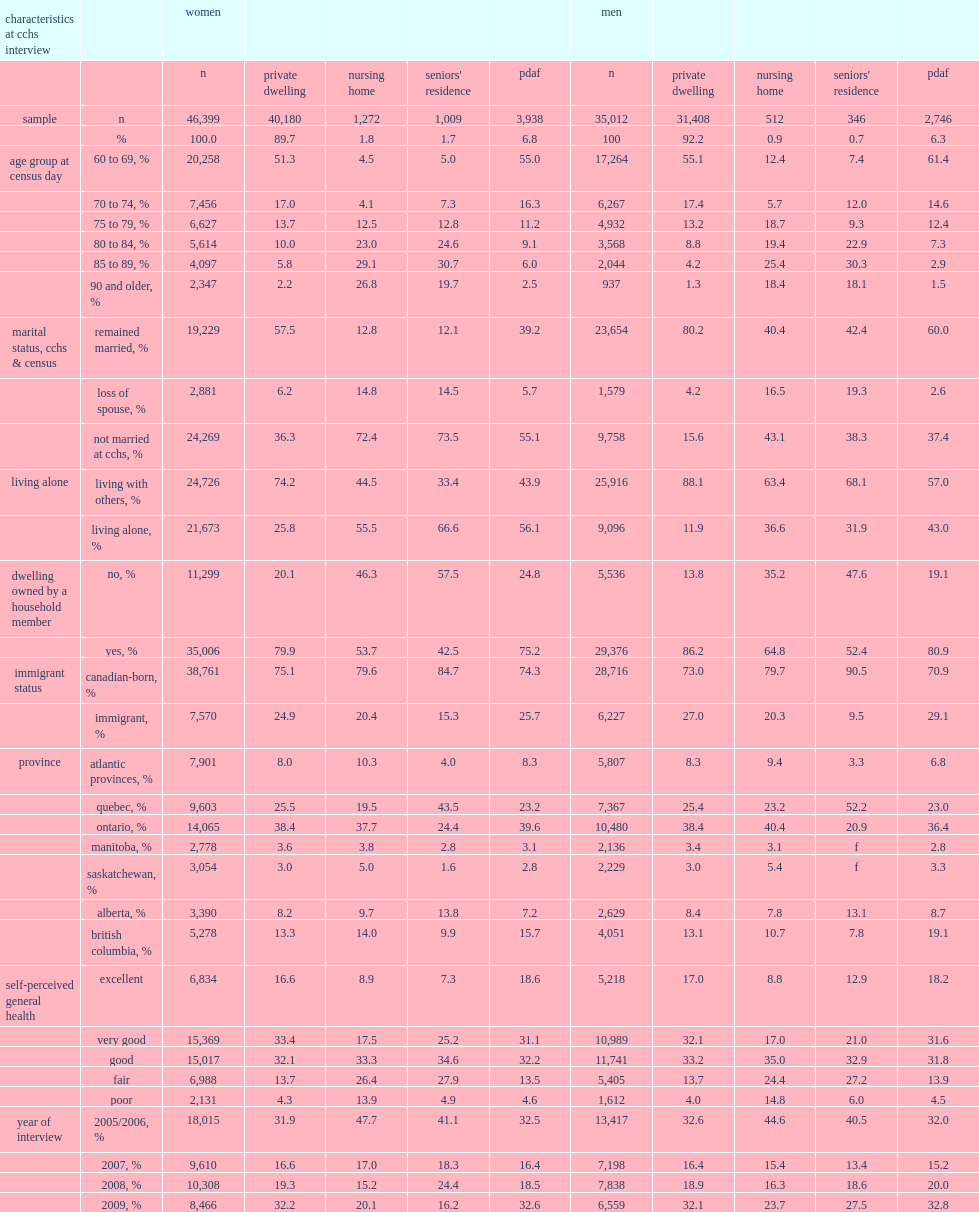Would you be able to parse every entry in this table? {'header': ['characteristics at cchs interview', '', 'women', '', '', '', '', 'men', '', '', '', ''], 'rows': [['', '', 'n', 'private dwelling', 'nursing home', "seniors' residence", 'pdaf', 'n', 'private dwelling', 'nursing home', "seniors' residence", 'pdaf'], ['sample', 'n', '46,399', '40,180', '1,272', '1,009', '3,938', '35,012', '31,408', '512', '346', '2,746'], ['', '%', '100.0', '89.7', '1.8', '1.7', '6.8', '100', '92.2', '0.9', '0.7', '6.3'], ['age group at census day', '60 to 69, %', '20,258', '51.3', '4.5', '5.0', '55.0', '17,264', '55.1', '12.4', '7.4', '61.4'], ['', '70 to 74, %', '7,456', '17.0', '4.1', '7.3', '16.3', '6,267', '17.4', '5.7', '12.0', '14.6'], ['', '75 to 79, %', '6,627', '13.7', '12.5', '12.8', '11.2', '4,932', '13.2', '18.7', '9.3', '12.4'], ['', '80 to 84, %', '5,614', '10.0', '23.0', '24.6', '9.1', '3,568', '8.8', '19.4', '22.9', '7.3'], ['', '85 to 89, %', '4,097', '5.8', '29.1', '30.7', '6.0', '2,044', '4.2', '25.4', '30.3', '2.9'], ['', '90 and older, %', '2,347', '2.2', '26.8', '19.7', '2.5', '937', '1.3', '18.4', '18.1', '1.5'], ['marital status, cchs & census', 'remained married, %', '19,229', '57.5', '12.8', '12.1', '39.2', '23,654', '80.2', '40.4', '42.4', '60.0'], ['', 'loss of spouse, %', '2,881', '6.2', '14.8', '14.5', '5.7', '1,579', '4.2', '16.5', '19.3', '2.6'], ['', 'not married at cchs, %', '24,269', '36.3', '72.4', '73.5', '55.1', '9,758', '15.6', '43.1', '38.3', '37.4'], ['living alone', 'living with others, %', '24,726', '74.2', '44.5', '33.4', '43.9', '25,916', '88.1', '63.4', '68.1', '57.0'], ['', 'living alone, %', '21,673', '25.8', '55.5', '66.6', '56.1', '9,096', '11.9', '36.6', '31.9', '43.0'], ['dwelling owned by a household member', 'no, %', '11,299', '20.1', '46.3', '57.5', '24.8', '5,536', '13.8', '35.2', '47.6', '19.1'], ['', 'yes, %', '35,006', '79.9', '53.7', '42.5', '75.2', '29,376', '86.2', '64.8', '52.4', '80.9'], ['immigrant status', 'canadian-born, %', '38,761', '75.1', '79.6', '84.7', '74.3', '28,716', '73.0', '79.7', '90.5', '70.9'], ['', 'immigrant, %', '7,570', '24.9', '20.4', '15.3', '25.7', '6,227', '27.0', '20.3', '9.5', '29.1'], ['province', 'atlantic provinces, %', '7,901', '8.0', '10.3', '4.0', '8.3', '5,807', '8.3', '9.4', '3.3', '6.8'], ['', 'quebec, %', '9,603', '25.5', '19.5', '43.5', '23.2', '7,367', '25.4', '23.2', '52.2', '23.0'], ['', 'ontario, %', '14,065', '38.4', '37.7', '24.4', '39.6', '10,480', '38.4', '40.4', '20.9', '36.4'], ['', 'manitoba, %', '2,778', '3.6', '3.8', '2.8', '3.1', '2,136', '3.4', '3.1', 'f', '2.8'], ['', 'saskatchewan, %', '3,054', '3.0', '5.0', '1.6', '2.8', '2,229', '3.0', '5.4', 'f', '3.3'], ['', 'alberta, %', '3,390', '8.2', '9.7', '13.8', '7.2', '2,629', '8.4', '7.8', '13.1', '8.7'], ['', 'british columbia, %', '5,278', '13.3', '14.0', '9.9', '15.7', '4,051', '13.1', '10.7', '7.8', '19.1'], ['self-perceived general health', 'excellent', '6,834', '16.6', '8.9', '7.3', '18.6', '5,218', '17.0', '8.8', '12.9', '18.2'], ['', 'very good', '15,369', '33.4', '17.5', '25.2', '31.1', '10,989', '32.1', '17.0', '21.0', '31.6'], ['', 'good', '15,017', '32.1', '33.3', '34.6', '32.2', '11,741', '33.2', '35.0', '32.9', '31.8'], ['', 'fair', '6,988', '13.7', '26.4', '27.9', '13.5', '5,405', '13.7', '24.4', '27.2', '13.9'], ['', 'poor', '2,131', '4.3', '13.9', '4.9', '4.6', '1,612', '4.0', '14.8', '6.0', '4.5'], ['year of interview', '2005/2006, %', '18,015', '31.9', '47.7', '41.1', '32.5', '13,417', '32.6', '44.6', '40.5', '32.0'], ['', '2007, %', '9,610', '16.6', '17.0', '18.3', '16.4', '7,198', '16.4', '15.4', '13.4', '15.2'], ['', '2008, %', '10,308', '19.3', '15.2', '24.4', '18.5', '7,838', '18.9', '16.3', '18.6', '20.0'], ['', '2009, %', '8,466', '32.2', '20.1', '16.2', '32.6', '6,559', '32.1', '23.7', '27.5', '32.8']]} In the analytic sample of cchs respondents linked to the census, how many respondents were living in an nh at the time of the census? 0.021914. In the analytic sample of cchs respondents linked to the census, how many respondents were living in an sr at the time of the census? 0.016644. In the analytic sample of cchs respondents linked to the census, how many respondents were living in a pdaf at the time of the census? 0.082102. Were women more likely to be living in an nh or were men? Women. Were women more likely to be living in an sr or were men? Women. Were women more likely to be living in a pdaf or were men? Women. Were women still living in a private dwelling on census day 2011 more likely to be unmarried or were those living in an nh at the time of the cchs interview? Nursing home. Were men still living in a private dwelling on census day 2011 more likely to be unmarried or were those living in an nh at the time of the cchs interview? Nursing home. Were women still living in a private dwelling on census day 2011 more likely to have lost their partner between the cchs interview and the census or were those living in an nh? Nursing home. Were men still living in a private dwelling on census day 2011 more likely to have lost their partner between the cchs interview and the census or were those living in an nh? Nursing home. Were women still living in a private dwelling on census day 2011 more likely to have been born in canada or were those living in an nh? Nursing home. Were men still living in a private dwelling on census day 2011 more likely to have been born in canada or were those living in an nh? Nursing home. Were women still living in a private dwelling on census day 2011 more likely to be unmarried or were those living in an sr at the time of the cchs interview? Seniors' residence. Were men still living in a private dwelling on census day 2011 more likely to be unmarried or were those living in an sr at the time of the cchs interview? Seniors' residence. Were women still living in a private dwelling on census day 2011 more likely to have lost their partner between the cchs interview and the census or were those living in an sr? Seniors' residence. Were men still living in a private dwelling on census day 2011 more likely to have lost their partner between the cchs interview and the census or were those living in an sr? Seniors' residence. Were women still living in a private dwelling on census day 2011 more likely to have been born in canada or were those living in an sr? Seniors' residence. Were men still living in a private dwelling on census day 2011 more likely to have been born in canada or were those living in an sr? Seniors' residence. Were women living in pdafs more likely to be unmarried at the time of the cchs interview or were those living in other private dwellings? Pdaf. Were men living in pdafs more likely to be unmarried at the time of the cchs interview or were those living in other private dwellings? Pdaf. Were women living in pdafs more likely to be living alone at the time of the cchs interview or were those living in other private dwellings? Pdaf. Were men living in pdafs more likely to be living alone at the time of the cchs interview or were those living in other private dwellings? Pdaf. 